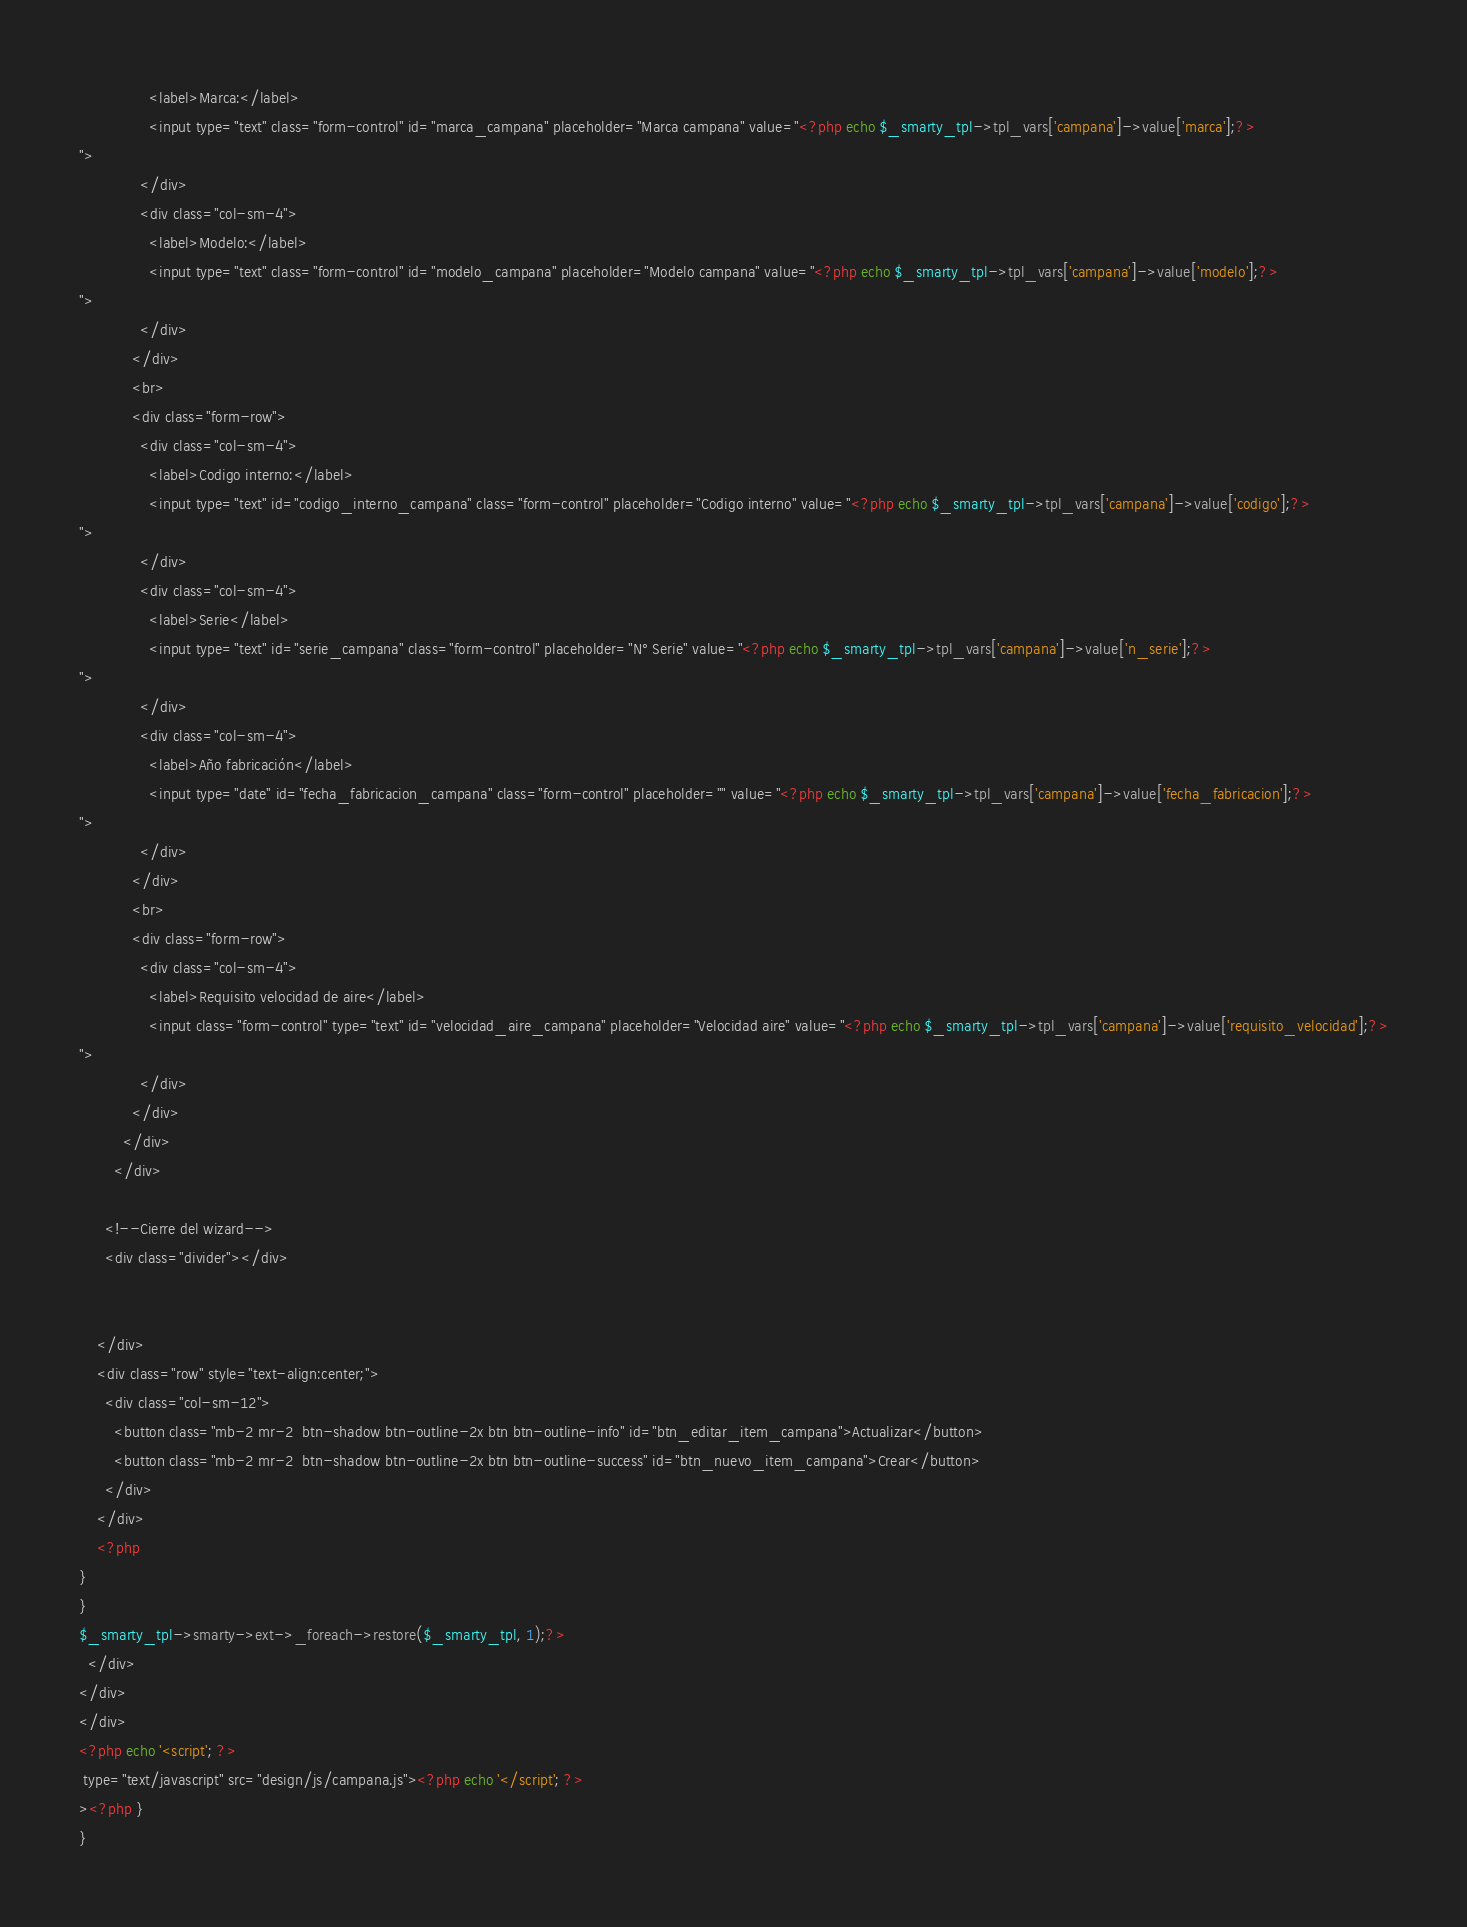<code> <loc_0><loc_0><loc_500><loc_500><_PHP_>                <label>Marca:</label>
                <input type="text" class="form-control" id="marca_campana" placeholder="Marca campana" value="<?php echo $_smarty_tpl->tpl_vars['campana']->value['marca'];?>
">
              </div>
              <div class="col-sm-4">
                <label>Modelo:</label>
                <input type="text" class="form-control" id="modelo_campana" placeholder="Modelo campana" value="<?php echo $_smarty_tpl->tpl_vars['campana']->value['modelo'];?>
">
              </div>
            </div>
            <br>
            <div class="form-row">
              <div class="col-sm-4">
                <label>Codigo interno:</label>
                <input type="text" id="codigo_interno_campana" class="form-control" placeholder="Codigo interno" value="<?php echo $_smarty_tpl->tpl_vars['campana']->value['codigo'];?>
">
              </div>
              <div class="col-sm-4">
                <label>Serie</label>
                <input type="text" id="serie_campana" class="form-control" placeholder="N° Serie" value="<?php echo $_smarty_tpl->tpl_vars['campana']->value['n_serie'];?>
">
              </div>
              <div class="col-sm-4">
                <label>Año fabricación</label>
                <input type="date" id="fecha_fabricacion_campana" class="form-control" placeholder="" value="<?php echo $_smarty_tpl->tpl_vars['campana']->value['fecha_fabricacion'];?>
">
              </div>
            </div>
            <br>
            <div class="form-row">
              <div class="col-sm-4">
                <label>Requisito velocidad de aire</label>
                <input class="form-control" type="text" id="velocidad_aire_campana" placeholder="Velocidad aire" value="<?php echo $_smarty_tpl->tpl_vars['campana']->value['requisito_velocidad'];?>
">
              </div>
            </div>
          </div>
        </div>
  
      <!--Cierre del wizard-->
      <div class="divider"></div>


    </div>
    <div class="row" style="text-align:center;">
      <div class="col-sm-12">
        <button class="mb-2 mr-2  btn-shadow btn-outline-2x btn btn-outline-info" id="btn_editar_item_campana">Actualizar</button>
        <button class="mb-2 mr-2  btn-shadow btn-outline-2x btn btn-outline-success" id="btn_nuevo_item_campana">Crear</button>
      </div>
    </div>
    <?php
}
}
$_smarty_tpl->smarty->ext->_foreach->restore($_smarty_tpl, 1);?>
  </div>
</div>
</div>
<?php echo '<script'; ?>
 type="text/javascript" src="design/js/campana.js"><?php echo '</script'; ?>
><?php }
}
</code> 